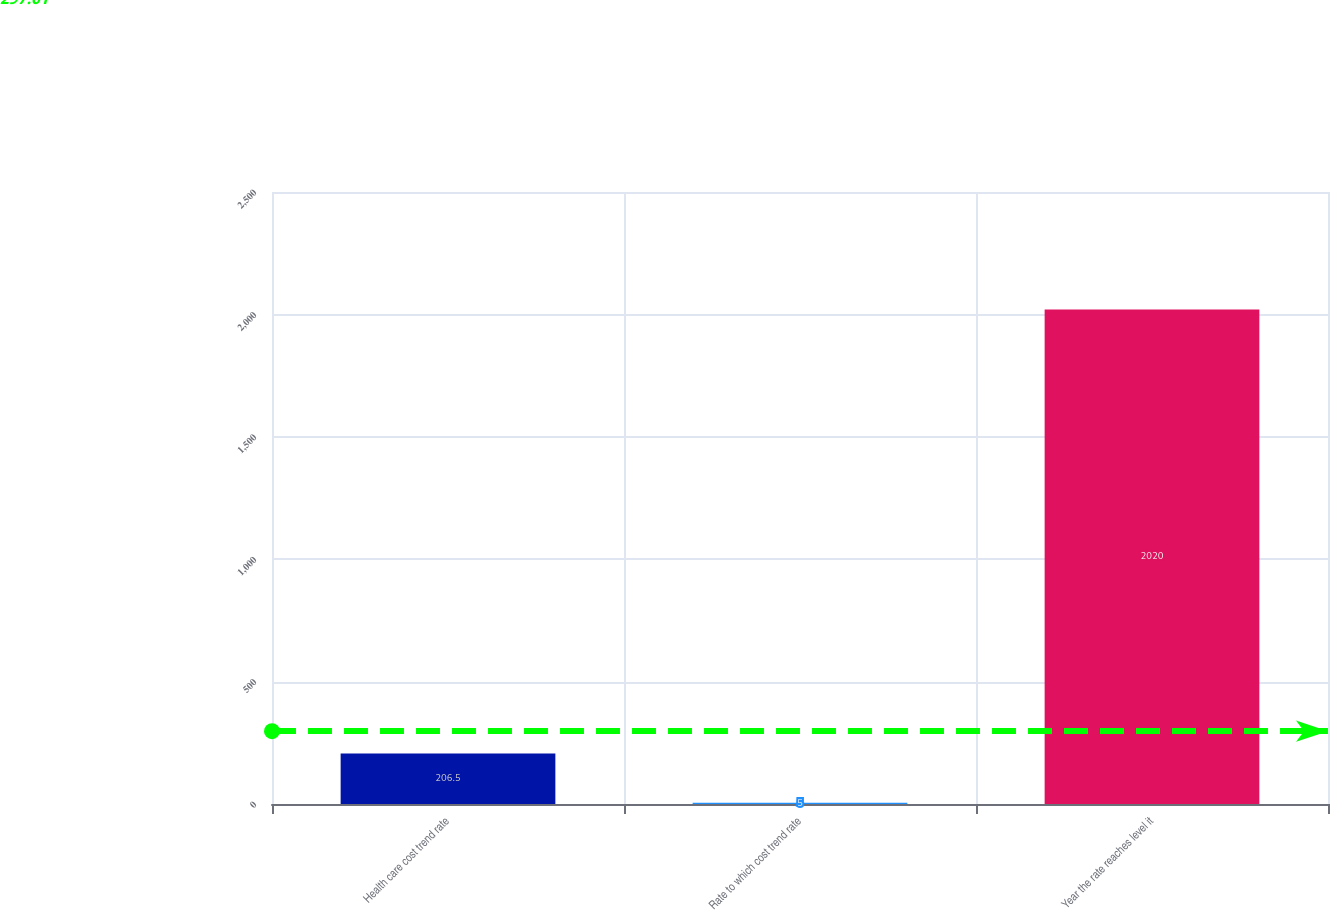Convert chart to OTSL. <chart><loc_0><loc_0><loc_500><loc_500><bar_chart><fcel>Health care cost trend rate<fcel>Rate to which cost trend rate<fcel>Year the rate reaches level it<nl><fcel>206.5<fcel>5<fcel>2020<nl></chart> 